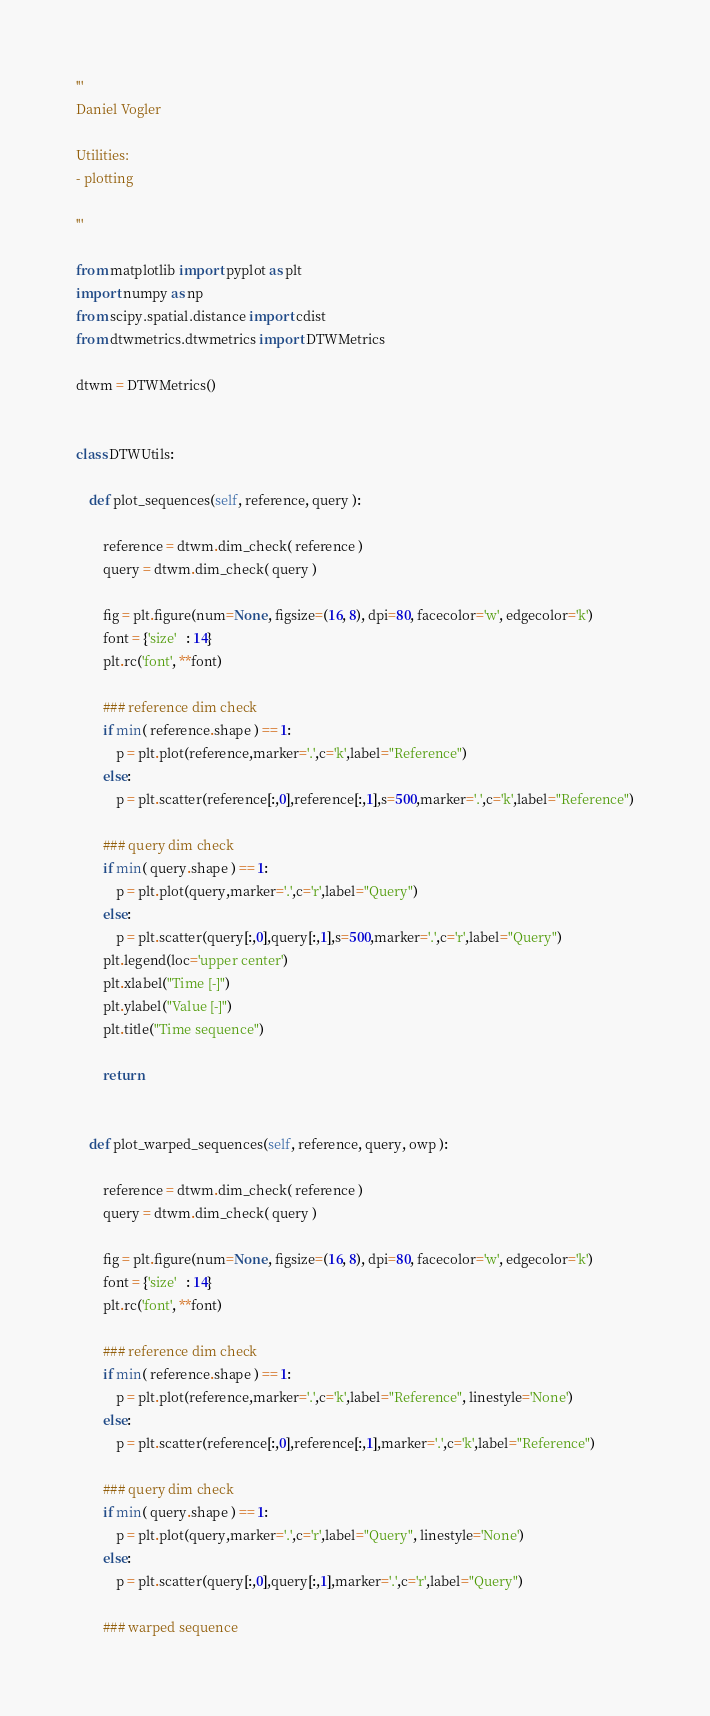<code> <loc_0><loc_0><loc_500><loc_500><_Python_>'''
Daniel Vogler
 
Utilities: 
- plotting 

'''

from matplotlib import pyplot as plt
import numpy as np
from scipy.spatial.distance import cdist
from dtwmetrics.dtwmetrics import DTWMetrics

dtwm = DTWMetrics()


class DTWUtils:

    def plot_sequences(self, reference, query ):

        reference = dtwm.dim_check( reference )
        query = dtwm.dim_check( query )

        fig = plt.figure(num=None, figsize=(16, 8), dpi=80, facecolor='w', edgecolor='k')
        font = {'size'   : 14}
        plt.rc('font', **font)
        
        ### reference dim check
        if min( reference.shape ) == 1:
            p = plt.plot(reference,marker='.',c='k',label="Reference")
        else:
            p = plt.scatter(reference[:,0],reference[:,1],s=500,marker='.',c='k',label="Reference")
        
        ### query dim check
        if min( query.shape ) == 1:
            p = plt.plot(query,marker='.',c='r',label="Query")
        else:
            p = plt.scatter(query[:,0],query[:,1],s=500,marker='.',c='r',label="Query")
        plt.legend(loc='upper center')
        plt.xlabel("Time [-]")
        plt.ylabel("Value [-]")
        plt.title("Time sequence")

        return


    def plot_warped_sequences(self, reference, query, owp ):

        reference = dtwm.dim_check( reference )
        query = dtwm.dim_check( query )

        fig = plt.figure(num=None, figsize=(16, 8), dpi=80, facecolor='w', edgecolor='k')
        font = {'size'   : 14}
        plt.rc('font', **font)
        
        ### reference dim check
        if min( reference.shape ) == 1:
            p = plt.plot(reference,marker='.',c='k',label="Reference", linestyle='None')
        else:
            p = plt.scatter(reference[:,0],reference[:,1],marker='.',c='k',label="Reference")
        
        ### query dim check
        if min( query.shape ) == 1:
            p = plt.plot(query,marker='.',c='r',label="Query", linestyle='None')
        else:
            p = plt.scatter(query[:,0],query[:,1],marker='.',c='r',label="Query")
        
        ### warped sequence</code> 